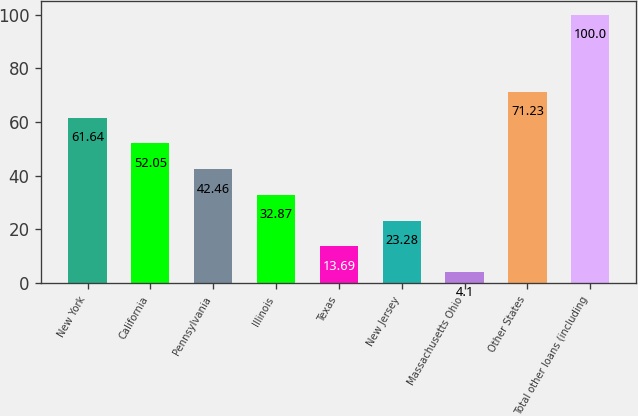Convert chart. <chart><loc_0><loc_0><loc_500><loc_500><bar_chart><fcel>New York<fcel>California<fcel>Pennsylvania<fcel>Illinois<fcel>Texas<fcel>New Jersey<fcel>Massachusetts Ohio<fcel>Other States<fcel>Total other loans (including<nl><fcel>61.64<fcel>52.05<fcel>42.46<fcel>32.87<fcel>13.69<fcel>23.28<fcel>4.1<fcel>71.23<fcel>100<nl></chart> 